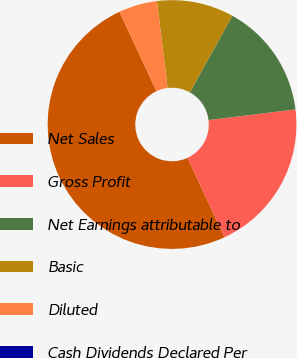Convert chart to OTSL. <chart><loc_0><loc_0><loc_500><loc_500><pie_chart><fcel>Net Sales<fcel>Gross Profit<fcel>Net Earnings attributable to<fcel>Basic<fcel>Diluted<fcel>Cash Dividends Declared Per<nl><fcel>50.0%<fcel>20.0%<fcel>15.0%<fcel>10.0%<fcel>5.0%<fcel>0.0%<nl></chart> 